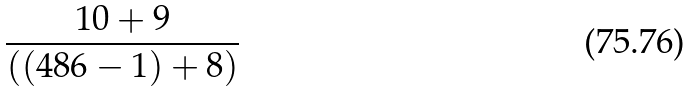<formula> <loc_0><loc_0><loc_500><loc_500>\frac { 1 0 + 9 } { ( ( 4 8 6 - 1 ) + 8 ) }</formula> 